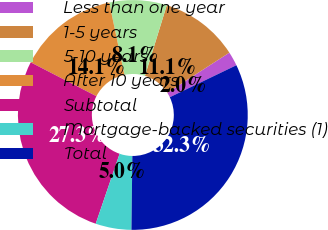Convert chart to OTSL. <chart><loc_0><loc_0><loc_500><loc_500><pie_chart><fcel>Less than one year<fcel>1-5 years<fcel>5-10 years<fcel>After 10 years<fcel>Subtotal<fcel>Mortgage-backed securities (1)<fcel>Total<nl><fcel>2.0%<fcel>11.1%<fcel>8.07%<fcel>14.13%<fcel>27.34%<fcel>5.04%<fcel>32.32%<nl></chart> 